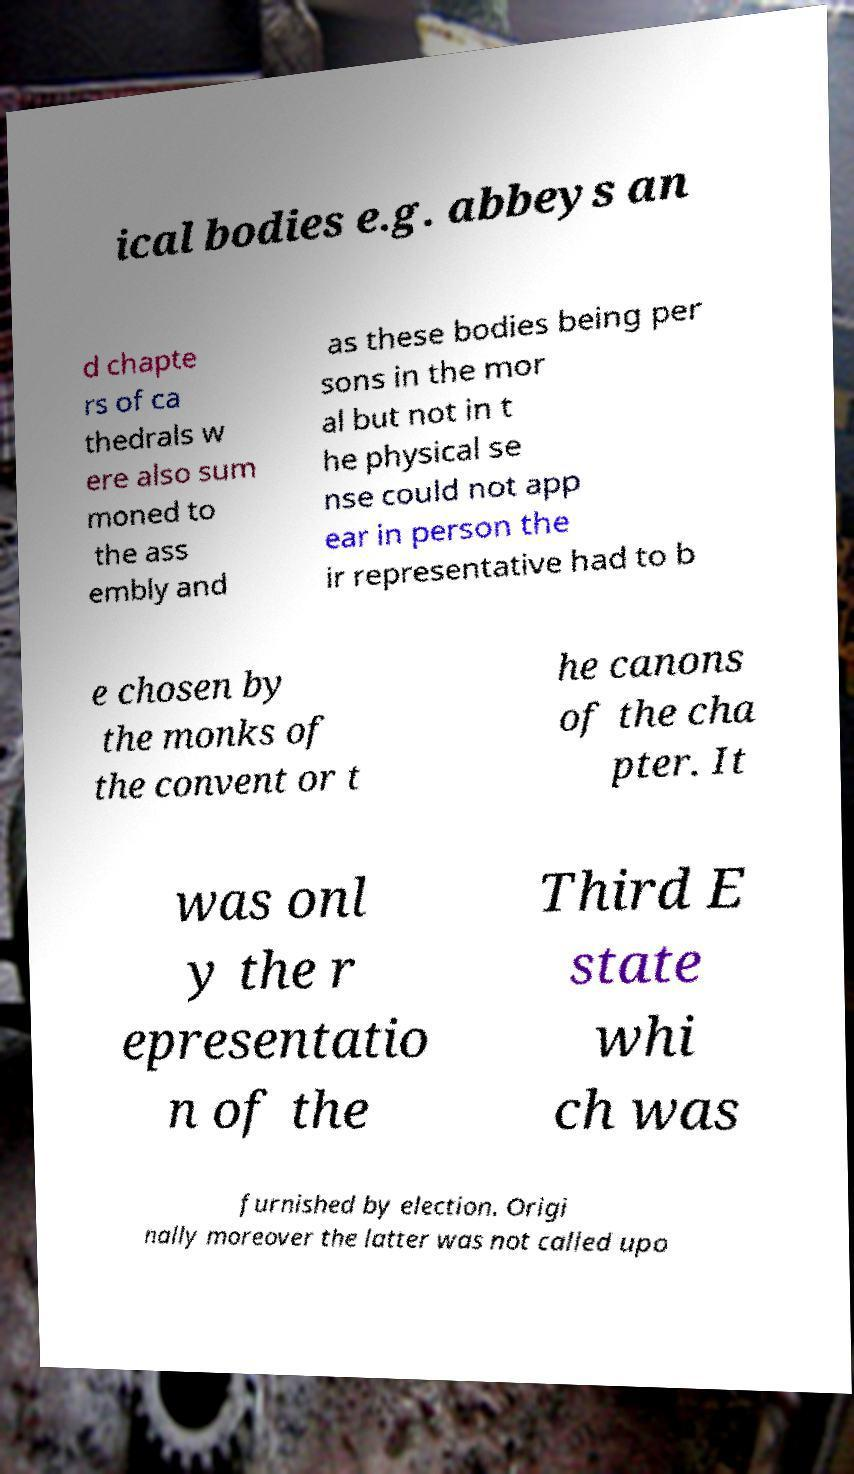Please read and relay the text visible in this image. What does it say? ical bodies e.g. abbeys an d chapte rs of ca thedrals w ere also sum moned to the ass embly and as these bodies being per sons in the mor al but not in t he physical se nse could not app ear in person the ir representative had to b e chosen by the monks of the convent or t he canons of the cha pter. It was onl y the r epresentatio n of the Third E state whi ch was furnished by election. Origi nally moreover the latter was not called upo 